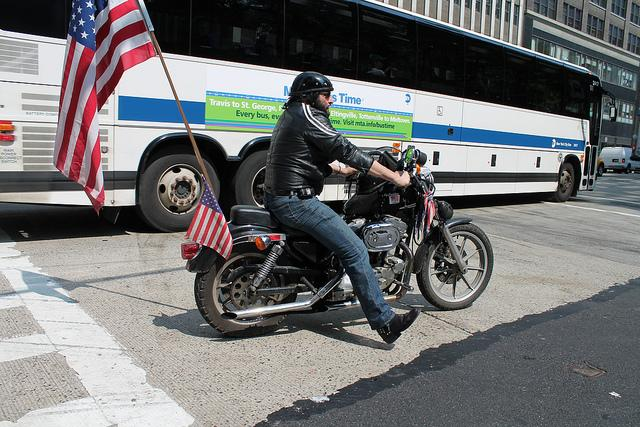Which one of these terms could be used to describe the motorcycle rider?

Choices:
A) patriotic
B) traitor
C) apolitical
D) anarchist patriotic 